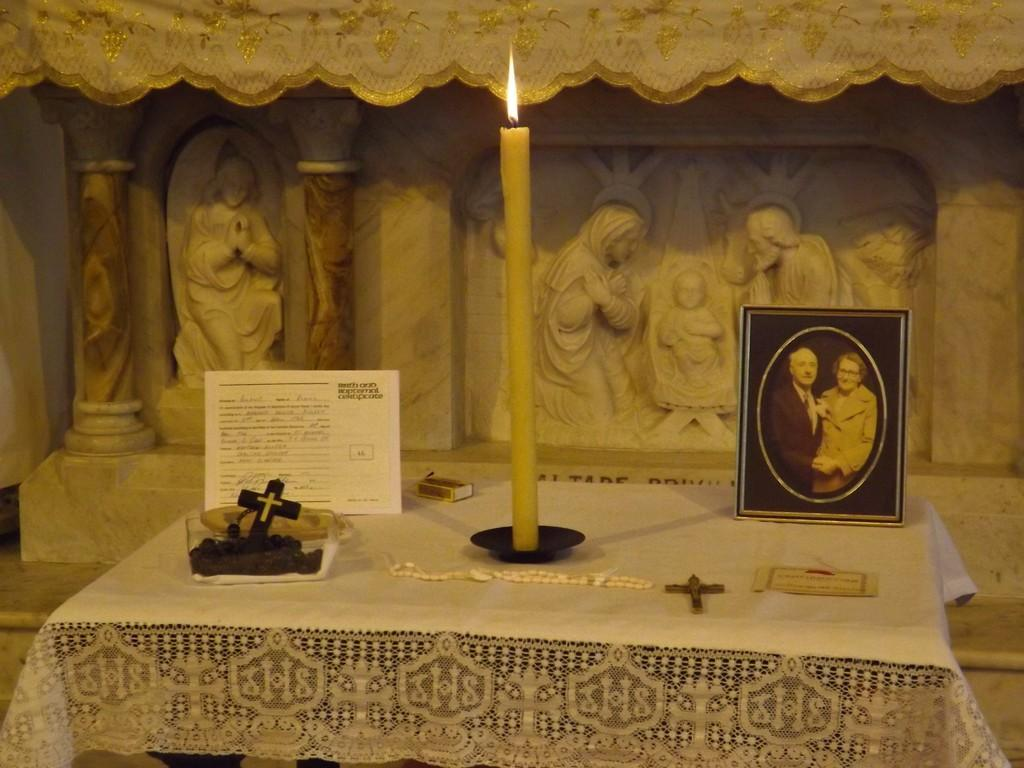What is the main object in the image? There is a frame in the image. What can be seen inside the frame? There is a candle and a cross symbol in the image. What is the color of the surface on which the objects are placed? The objects are on a white color surface. What type of objects can be seen in the background of the image? There are statues in the background of the image. What type of nation is depicted in the image? There is no nation depicted in the image; it features a frame with a candle, a cross symbol, and statues in the background. Can you tell me how much cream is used in the image? There is no cream present in the image. 